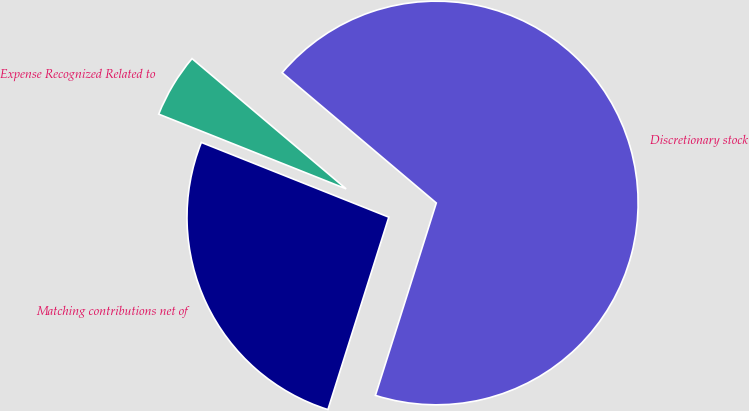<chart> <loc_0><loc_0><loc_500><loc_500><pie_chart><fcel>Expense Recognized Related to<fcel>Matching contributions net of<fcel>Discretionary stock<nl><fcel>5.13%<fcel>26.16%<fcel>68.71%<nl></chart> 